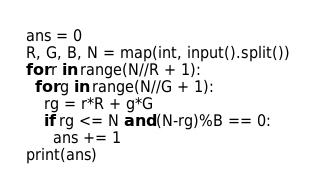<code> <loc_0><loc_0><loc_500><loc_500><_Python_>ans = 0
R, G, B, N = map(int, input().split())
for r in range(N//R + 1):
  for g in range(N//G + 1):
    rg = r*R + g*G
    if rg <= N and (N-rg)%B == 0:
      ans += 1
print(ans)</code> 